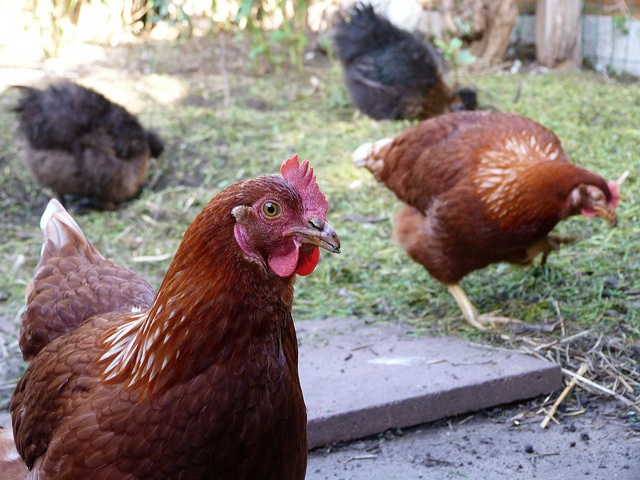Describe the objects in this image and their specific colors. I can see bird in lightyellow, black, maroon, and brown tones, bird in lightyellow, maroon, brown, black, and lightpink tones, bird in lightyellow, black, and gray tones, and bird in lightyellow, gray, black, and maroon tones in this image. 